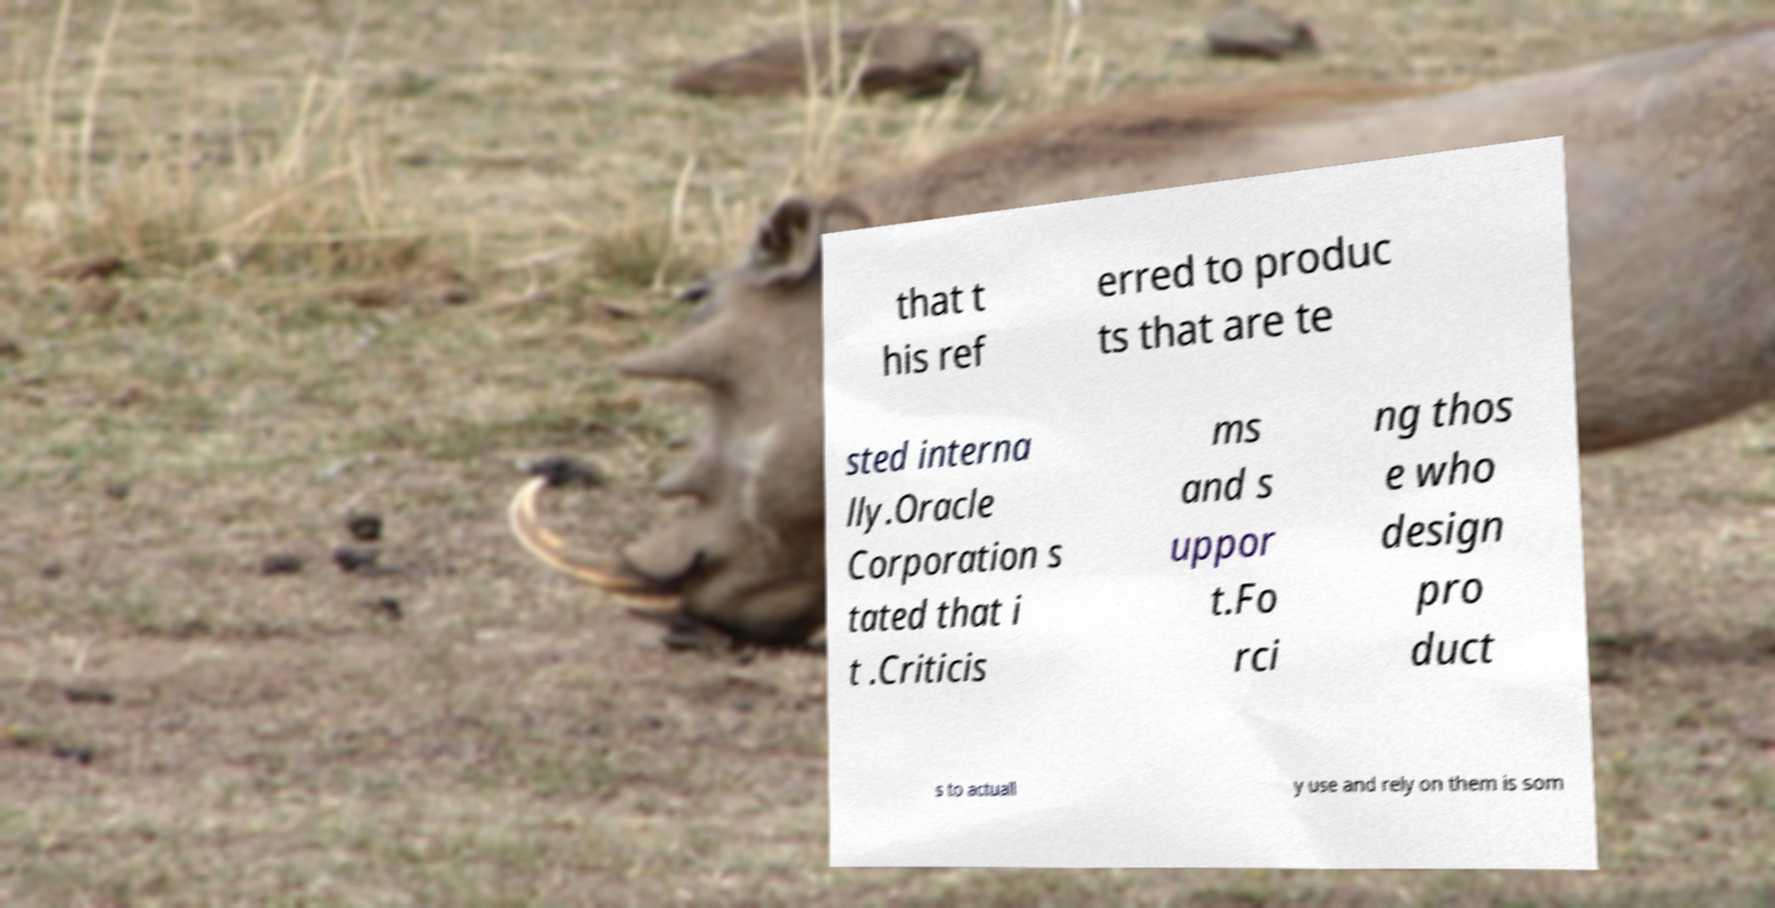There's text embedded in this image that I need extracted. Can you transcribe it verbatim? that t his ref erred to produc ts that are te sted interna lly.Oracle Corporation s tated that i t .Criticis ms and s uppor t.Fo rci ng thos e who design pro duct s to actuall y use and rely on them is som 